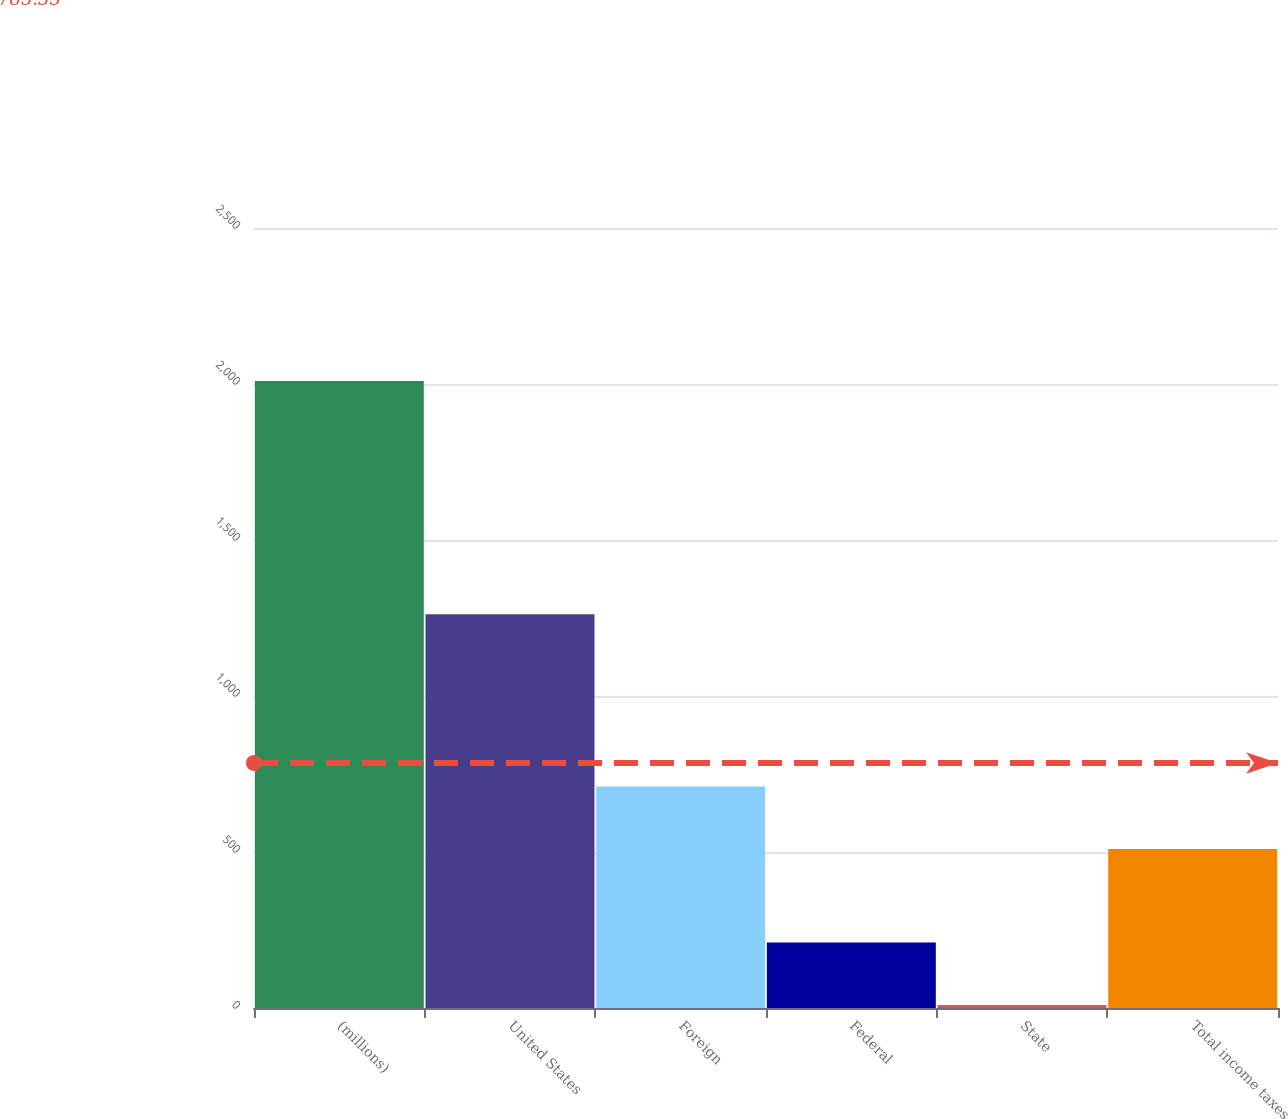<chart> <loc_0><loc_0><loc_500><loc_500><bar_chart><fcel>(millions)<fcel>United States<fcel>Foreign<fcel>Federal<fcel>State<fcel>Total income taxes<nl><fcel>2010<fcel>1262<fcel>710<fcel>210<fcel>10<fcel>510<nl></chart> 